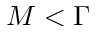Convert formula to latex. <formula><loc_0><loc_0><loc_500><loc_500>M < \Gamma</formula> 